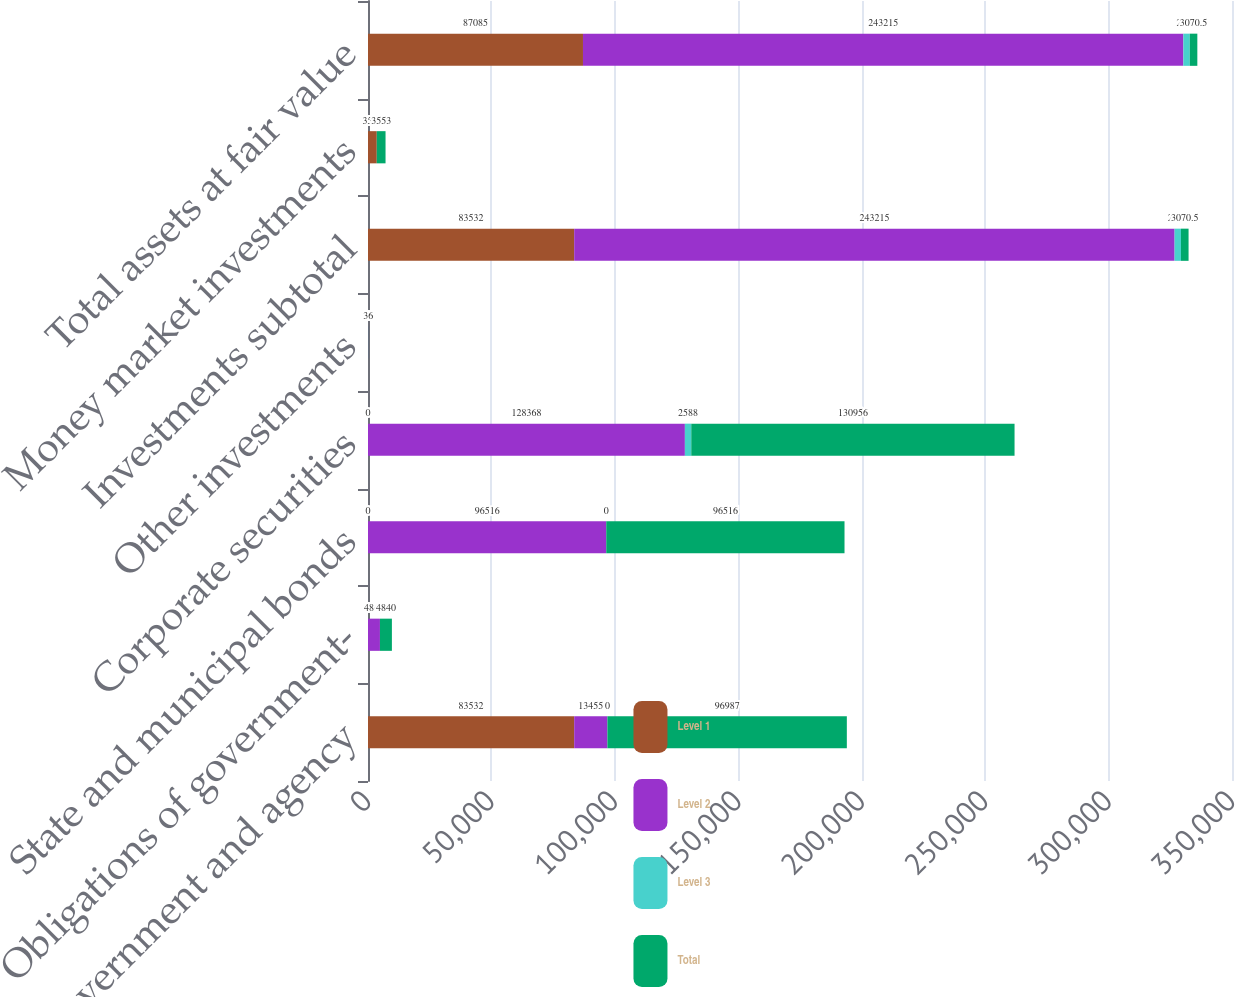Convert chart. <chart><loc_0><loc_0><loc_500><loc_500><stacked_bar_chart><ecel><fcel>US government and agency<fcel>Obligations of government-<fcel>State and municipal bonds<fcel>Corporate securities<fcel>Other investments<fcel>Investments subtotal<fcel>Money market investments<fcel>Total assets at fair value<nl><fcel>Level 1<fcel>83532<fcel>0<fcel>0<fcel>0<fcel>0<fcel>83532<fcel>3553<fcel>87085<nl><fcel>Level 2<fcel>13455<fcel>4840<fcel>96516<fcel>128368<fcel>36<fcel>243215<fcel>0<fcel>243215<nl><fcel>Level 3<fcel>0<fcel>0<fcel>0<fcel>2588<fcel>0<fcel>2588<fcel>0<fcel>2588<nl><fcel>Total<fcel>96987<fcel>4840<fcel>96516<fcel>130956<fcel>36<fcel>3070.5<fcel>3553<fcel>3070.5<nl></chart> 